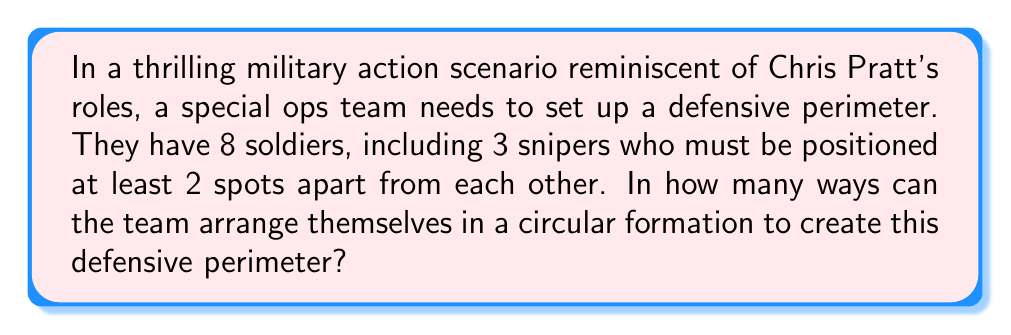Show me your answer to this math problem. Let's approach this step-by-step:

1) First, we need to consider that this is a circular arrangement, so rotations of the same arrangement are considered identical. We can fix the position of one soldier to account for this.

2) We have 8 soldiers in total, so we're dealing with 7! permutations after fixing one soldier.

3) However, we need to consider the special condition for the 3 snipers. Let's place the snipers first:

   a) We have 8 positions, and we need to choose 3 for the snipers, with at least 2 spots between each.
   b) We can think of this as choosing 3 positions out of 6 available ones (imagine the circle divided into 6 sections with a space between each).
   c) This can be calculated as $\binom{6}{3}$.

4) After placing the snipers, we need to arrange the remaining 5 soldiers in the 5 open spots.

5) The total number of arrangements is therefore:

   $$\binom{6}{3} \cdot 5!$$

6) Calculate:
   $$\binom{6}{3} = \frac{6!}{3!(6-3)!} = \frac{6!}{3!3!} = 20$$
   
   $$20 \cdot 5! = 20 \cdot 120 = 2400$$

Thus, there are 2400 possible arrangements.
Answer: 2400 